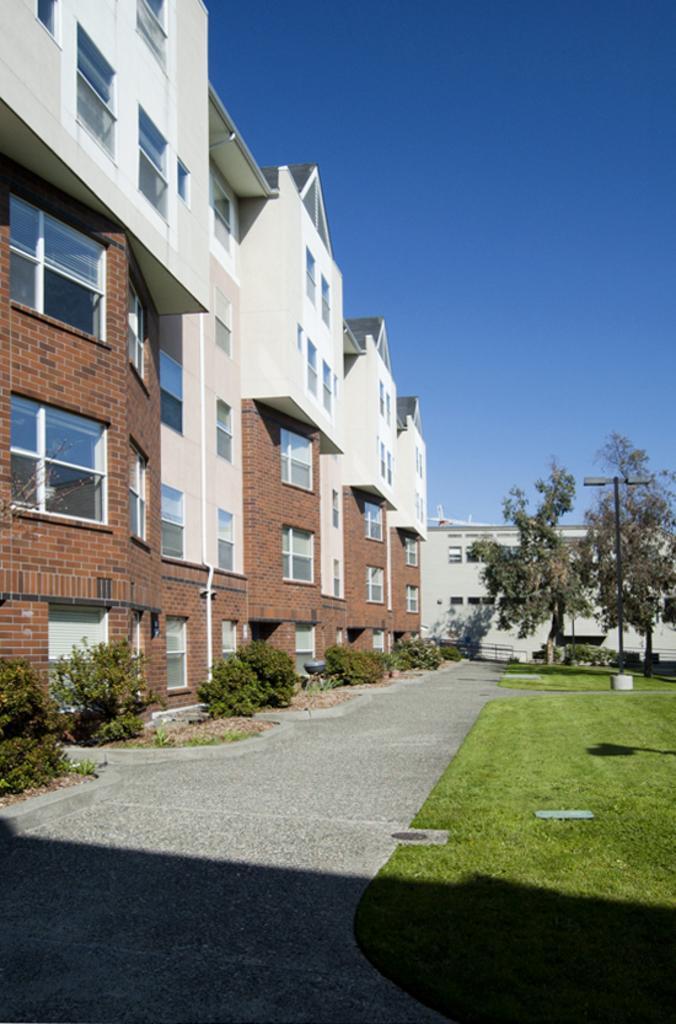How would you summarize this image in a sentence or two? In this image I can see a path, grass, plants, few trees, few lights, few buildings and in the background I can see the sky. I can also see shadows over here. 